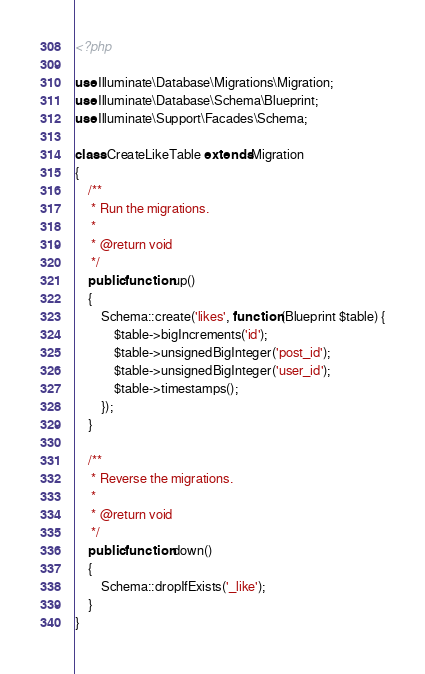<code> <loc_0><loc_0><loc_500><loc_500><_PHP_><?php

use Illuminate\Database\Migrations\Migration;
use Illuminate\Database\Schema\Blueprint;
use Illuminate\Support\Facades\Schema;

class CreateLikeTable extends Migration
{
    /**
     * Run the migrations.
     *
     * @return void
     */
    public function up()
    {
        Schema::create('likes', function (Blueprint $table) {
            $table->bigIncrements('id');
            $table->unsignedBigInteger('post_id');
            $table->unsignedBigInteger('user_id');
            $table->timestamps();
        });
    }

    /**
     * Reverse the migrations.
     *
     * @return void
     */
    public function down()
    {
        Schema::dropIfExists('_like');
    }
}
</code> 